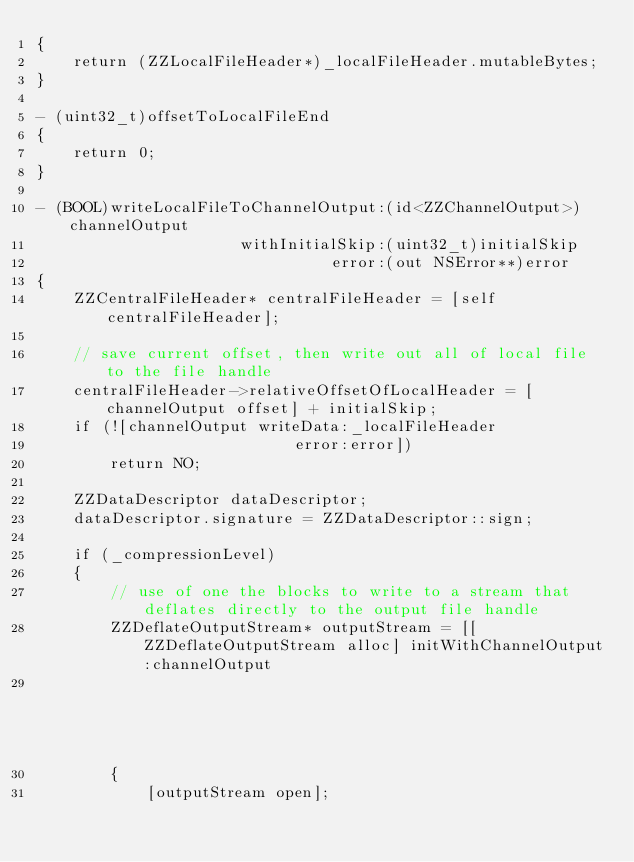<code> <loc_0><loc_0><loc_500><loc_500><_ObjectiveC_>{
	return (ZZLocalFileHeader*)_localFileHeader.mutableBytes;
}

- (uint32_t)offsetToLocalFileEnd
{
	return 0;
}

- (BOOL)writeLocalFileToChannelOutput:(id<ZZChannelOutput>)channelOutput
					  withInitialSkip:(uint32_t)initialSkip
								error:(out NSError**)error
{
	ZZCentralFileHeader* centralFileHeader = [self centralFileHeader];
	
	// save current offset, then write out all of local file to the file handle
	centralFileHeader->relativeOffsetOfLocalHeader = [channelOutput offset] + initialSkip;
	if (![channelOutput writeData:_localFileHeader
							error:error])
		return NO;
	
	ZZDataDescriptor dataDescriptor;
	dataDescriptor.signature = ZZDataDescriptor::sign;
	
	if (_compressionLevel)
	{
		// use of one the blocks to write to a stream that deflates directly to the output file handle
		ZZDeflateOutputStream* outputStream = [[ZZDeflateOutputStream alloc] initWithChannelOutput:channelOutput
																				  compressionLevel:_compressionLevel];
		{
			[outputStream open];</code> 